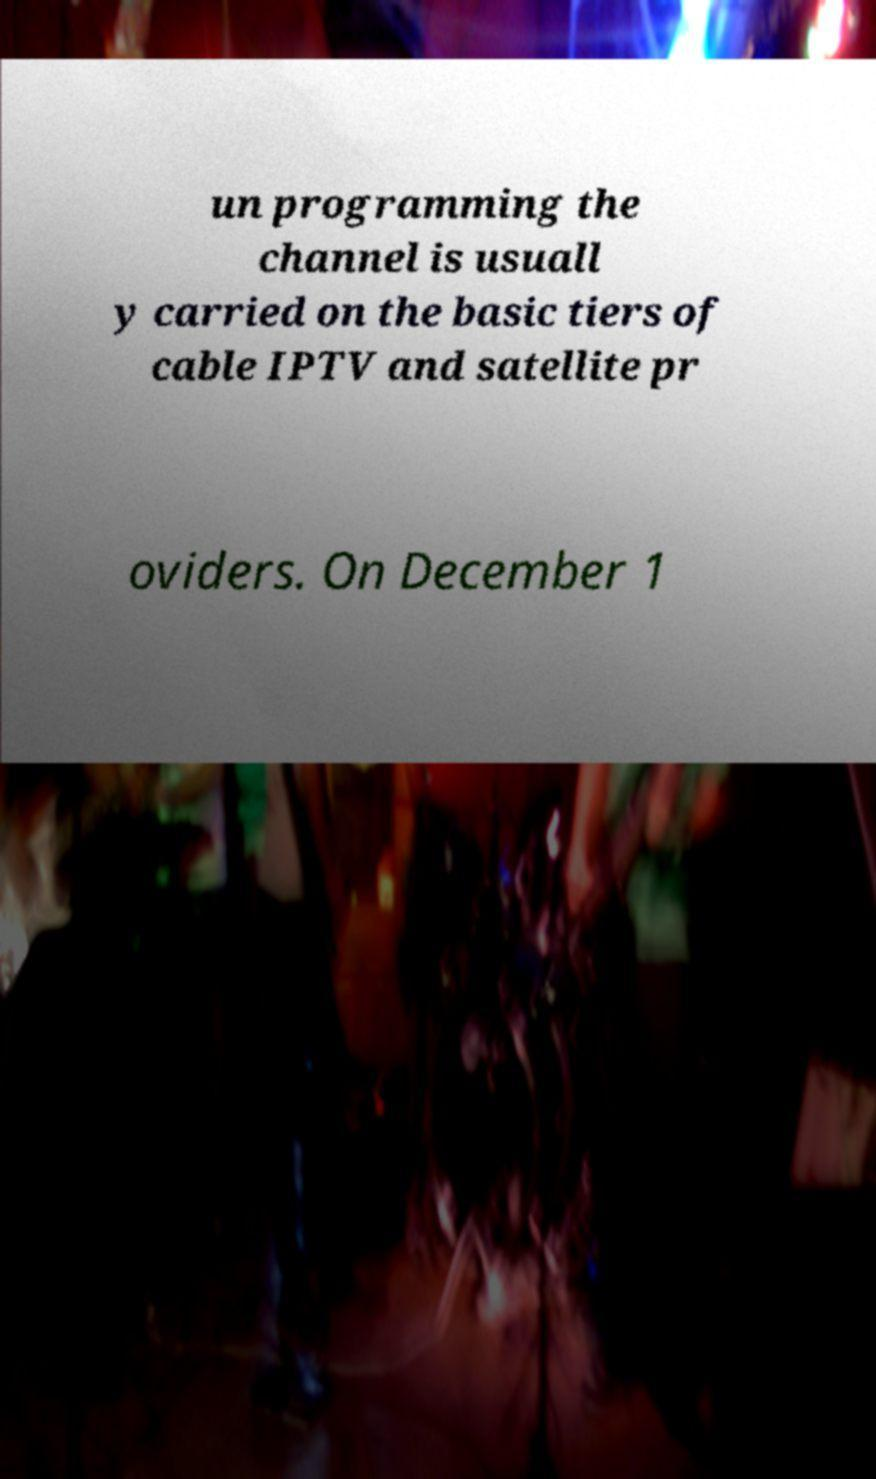Can you accurately transcribe the text from the provided image for me? un programming the channel is usuall y carried on the basic tiers of cable IPTV and satellite pr oviders. On December 1 